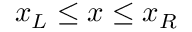Convert formula to latex. <formula><loc_0><loc_0><loc_500><loc_500>x _ { L } \leq x \leq x _ { R }</formula> 